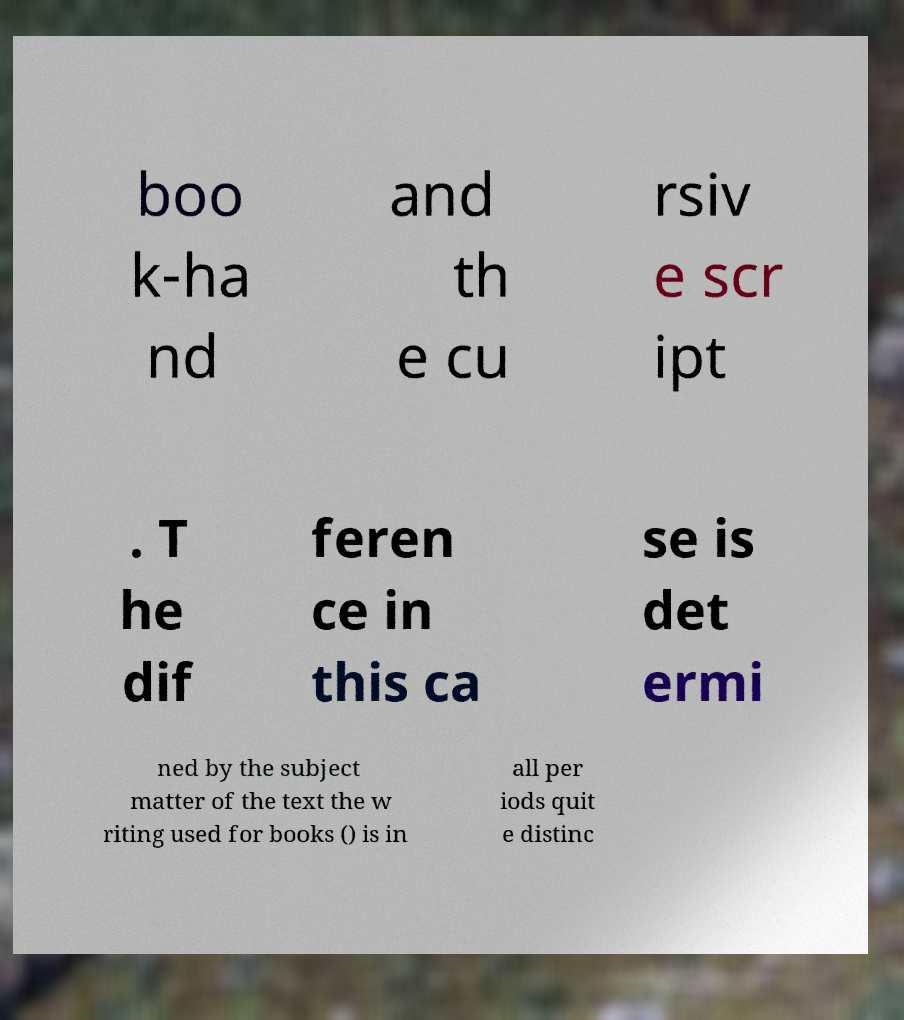Can you read and provide the text displayed in the image?This photo seems to have some interesting text. Can you extract and type it out for me? boo k-ha nd and th e cu rsiv e scr ipt . T he dif feren ce in this ca se is det ermi ned by the subject matter of the text the w riting used for books () is in all per iods quit e distinc 